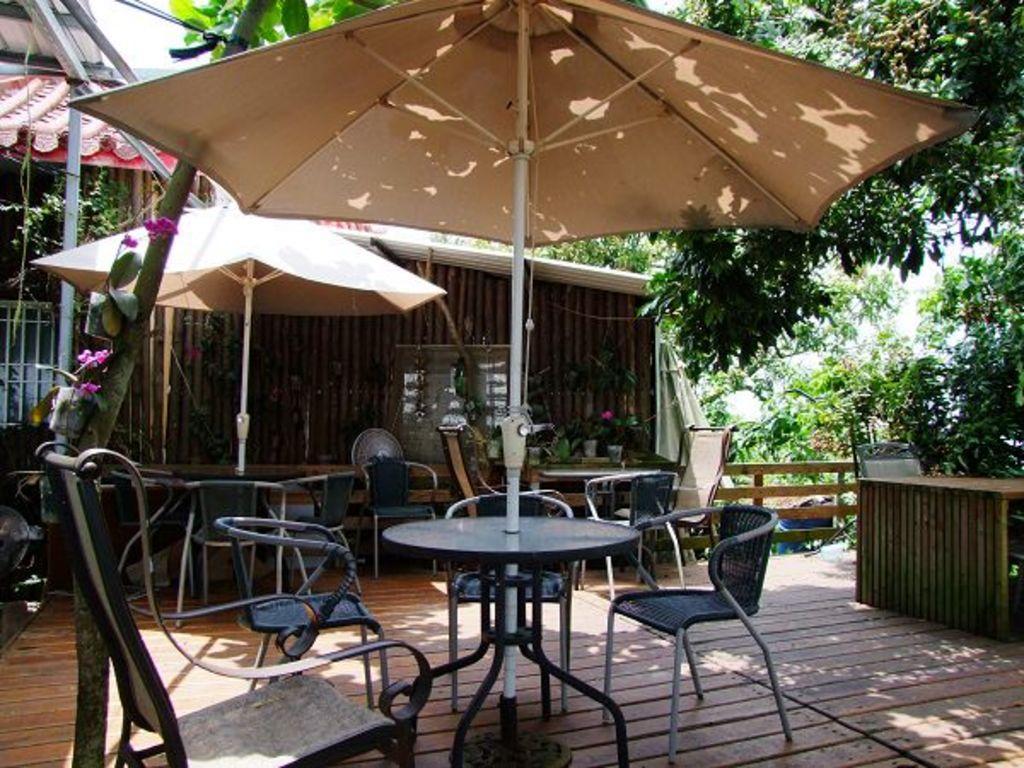Describe this image in one or two sentences. In this picture we can see few chairs, tables and an umbrellas, in the background we can find a house, metal rods and trees. 